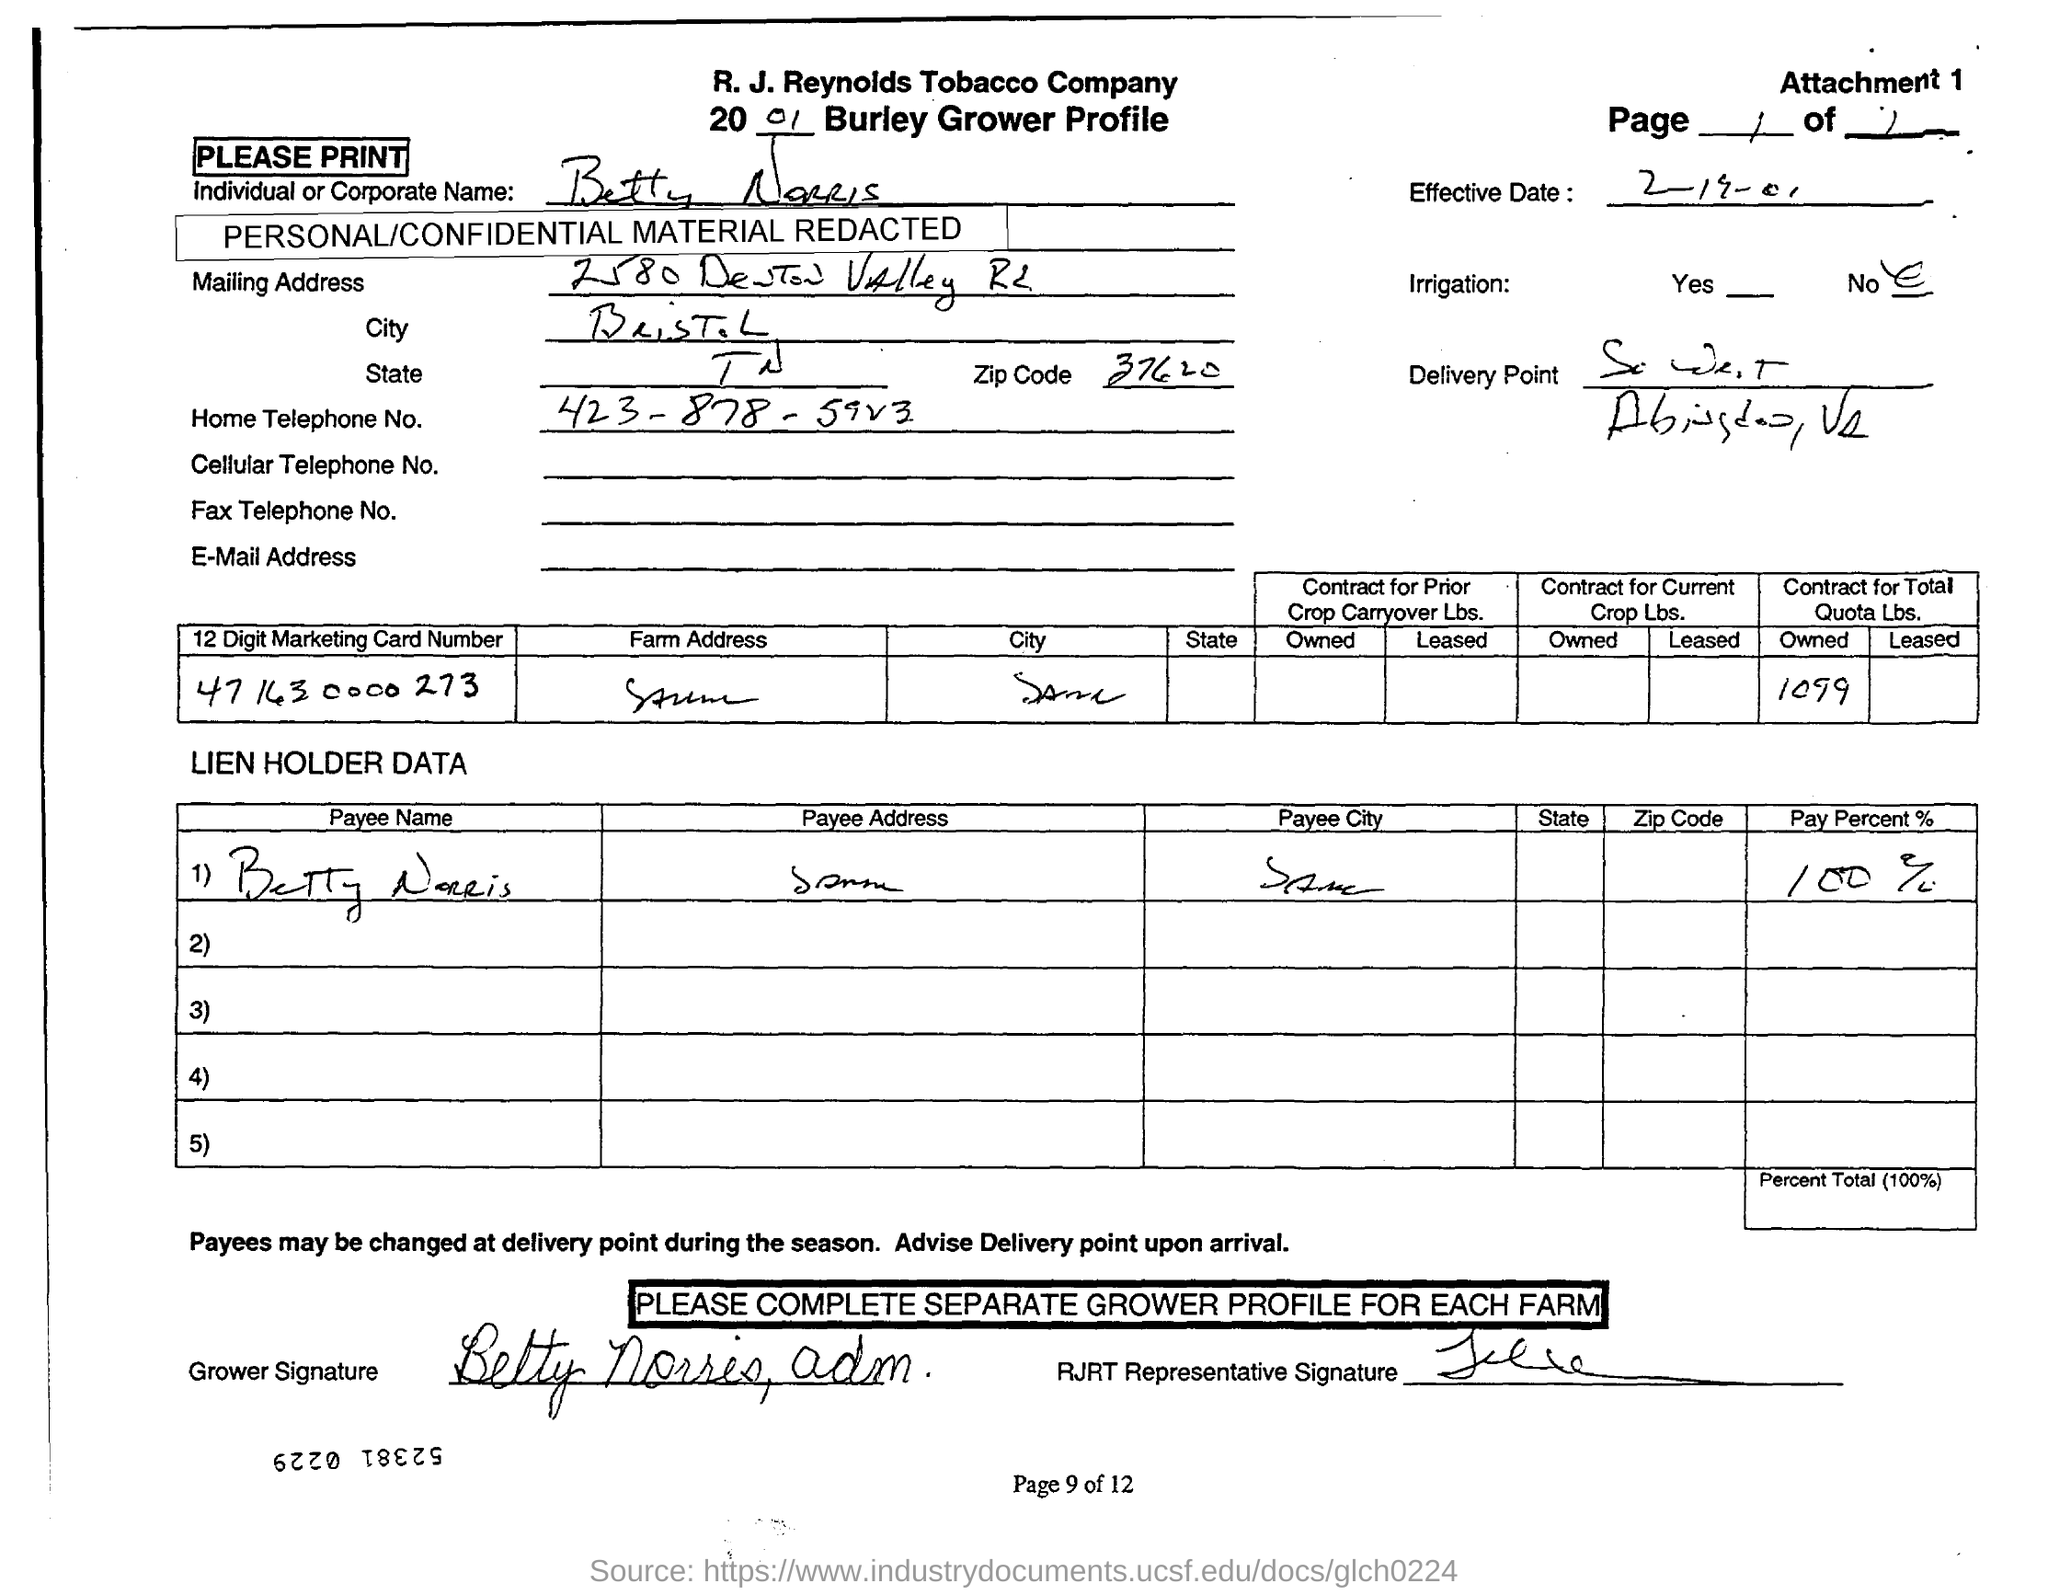Which company's grower profile is given here?
Make the answer very short. R. J. Reynolds Tobacco Company. What is the payee name mentioned in the document?
Ensure brevity in your answer.  Betty Norris. What is the pay percent given in the document?
Your answer should be compact. 100%. What is the effective date mentioned in the document?
Your answer should be very brief. 2-19-01. What is the zip code no given in the address?
Offer a terse response. 37620. What is the home telephone no of Betty Norris?
Provide a short and direct response. 423-878-5923. What is the digit marketing card number given in the document?
Your response must be concise. 47 163 0000 273. 